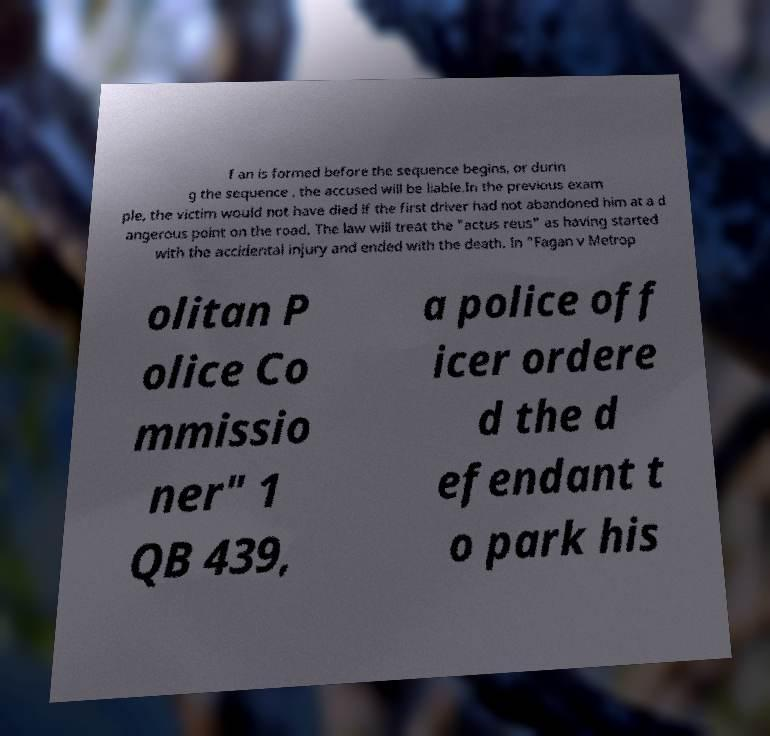I need the written content from this picture converted into text. Can you do that? f an is formed before the sequence begins, or durin g the sequence , the accused will be liable.In the previous exam ple, the victim would not have died if the first driver had not abandoned him at a d angerous point on the road. The law will treat the "actus reus" as having started with the accidental injury and ended with the death. In "Fagan v Metrop olitan P olice Co mmissio ner" 1 QB 439, a police off icer ordere d the d efendant t o park his 